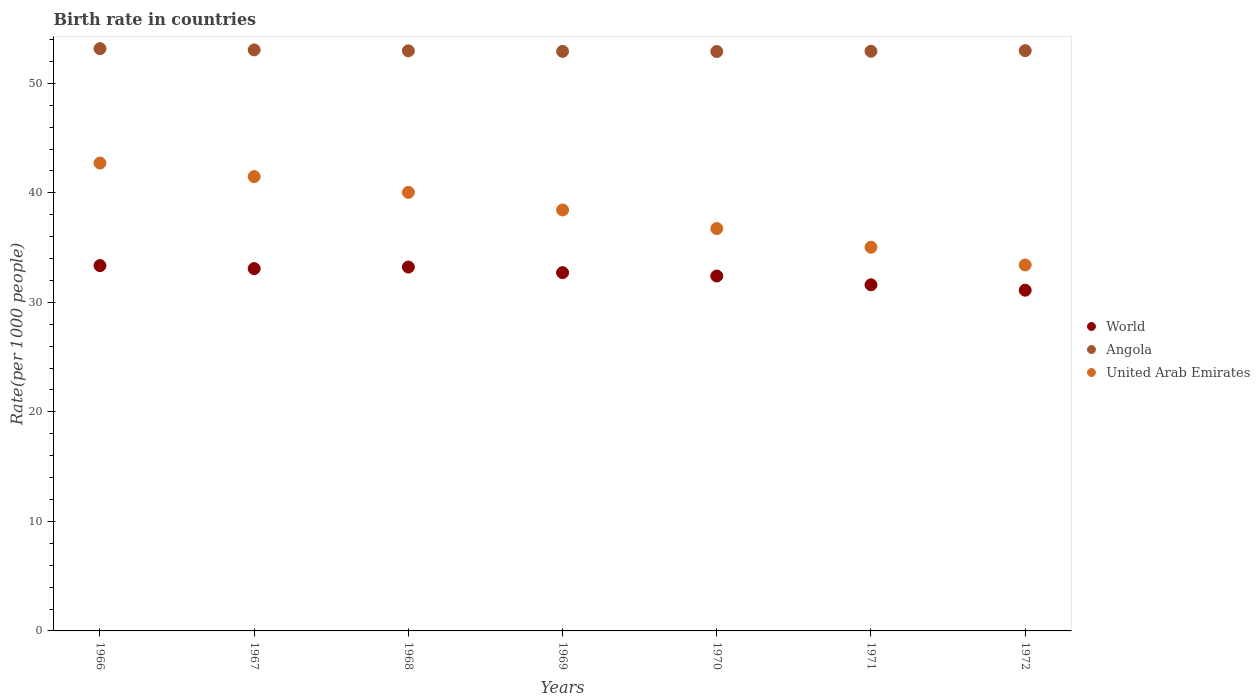Is the number of dotlines equal to the number of legend labels?
Provide a short and direct response. Yes. What is the birth rate in World in 1969?
Provide a short and direct response. 32.71. Across all years, what is the maximum birth rate in World?
Provide a succinct answer. 33.36. Across all years, what is the minimum birth rate in Angola?
Your answer should be very brief. 52.91. In which year was the birth rate in World maximum?
Offer a terse response. 1966. What is the total birth rate in United Arab Emirates in the graph?
Your response must be concise. 267.87. What is the difference between the birth rate in Angola in 1968 and that in 1970?
Make the answer very short. 0.06. What is the difference between the birth rate in United Arab Emirates in 1966 and the birth rate in World in 1972?
Offer a terse response. 11.61. What is the average birth rate in Angola per year?
Your answer should be very brief. 52.99. In the year 1967, what is the difference between the birth rate in United Arab Emirates and birth rate in Angola?
Your answer should be compact. -11.57. What is the ratio of the birth rate in Angola in 1966 to that in 1971?
Provide a succinct answer. 1. Is the birth rate in United Arab Emirates in 1966 less than that in 1969?
Give a very brief answer. No. Is the difference between the birth rate in United Arab Emirates in 1966 and 1971 greater than the difference between the birth rate in Angola in 1966 and 1971?
Provide a succinct answer. Yes. What is the difference between the highest and the second highest birth rate in World?
Provide a short and direct response. 0.13. What is the difference between the highest and the lowest birth rate in Angola?
Keep it short and to the point. 0.26. In how many years, is the birth rate in Angola greater than the average birth rate in Angola taken over all years?
Keep it short and to the point. 2. Does the birth rate in World monotonically increase over the years?
Offer a very short reply. No. How many dotlines are there?
Provide a succinct answer. 3. Are the values on the major ticks of Y-axis written in scientific E-notation?
Offer a very short reply. No. Does the graph contain any zero values?
Your answer should be compact. No. What is the title of the graph?
Make the answer very short. Birth rate in countries. Does "Burkina Faso" appear as one of the legend labels in the graph?
Your answer should be very brief. No. What is the label or title of the Y-axis?
Your answer should be compact. Rate(per 1000 people). What is the Rate(per 1000 people) in World in 1966?
Provide a succinct answer. 33.36. What is the Rate(per 1000 people) of Angola in 1966?
Give a very brief answer. 53.17. What is the Rate(per 1000 people) in United Arab Emirates in 1966?
Offer a very short reply. 42.72. What is the Rate(per 1000 people) of World in 1967?
Provide a succinct answer. 33.08. What is the Rate(per 1000 people) in Angola in 1967?
Provide a short and direct response. 53.05. What is the Rate(per 1000 people) of United Arab Emirates in 1967?
Offer a very short reply. 41.48. What is the Rate(per 1000 people) of World in 1968?
Provide a short and direct response. 33.22. What is the Rate(per 1000 people) in Angola in 1968?
Make the answer very short. 52.97. What is the Rate(per 1000 people) of United Arab Emirates in 1968?
Offer a terse response. 40.04. What is the Rate(per 1000 people) in World in 1969?
Offer a very short reply. 32.71. What is the Rate(per 1000 people) in Angola in 1969?
Your response must be concise. 52.92. What is the Rate(per 1000 people) of United Arab Emirates in 1969?
Offer a terse response. 38.44. What is the Rate(per 1000 people) of World in 1970?
Ensure brevity in your answer.  32.41. What is the Rate(per 1000 people) of Angola in 1970?
Offer a very short reply. 52.91. What is the Rate(per 1000 people) in United Arab Emirates in 1970?
Give a very brief answer. 36.74. What is the Rate(per 1000 people) of World in 1971?
Your response must be concise. 31.6. What is the Rate(per 1000 people) in Angola in 1971?
Keep it short and to the point. 52.93. What is the Rate(per 1000 people) of United Arab Emirates in 1971?
Provide a short and direct response. 35.03. What is the Rate(per 1000 people) in World in 1972?
Make the answer very short. 31.11. What is the Rate(per 1000 people) in Angola in 1972?
Provide a succinct answer. 52.98. What is the Rate(per 1000 people) in United Arab Emirates in 1972?
Keep it short and to the point. 33.41. Across all years, what is the maximum Rate(per 1000 people) of World?
Keep it short and to the point. 33.36. Across all years, what is the maximum Rate(per 1000 people) in Angola?
Make the answer very short. 53.17. Across all years, what is the maximum Rate(per 1000 people) in United Arab Emirates?
Your response must be concise. 42.72. Across all years, what is the minimum Rate(per 1000 people) of World?
Make the answer very short. 31.11. Across all years, what is the minimum Rate(per 1000 people) of Angola?
Provide a succinct answer. 52.91. Across all years, what is the minimum Rate(per 1000 people) in United Arab Emirates?
Provide a short and direct response. 33.41. What is the total Rate(per 1000 people) of World in the graph?
Your answer should be very brief. 227.5. What is the total Rate(per 1000 people) of Angola in the graph?
Provide a short and direct response. 370.92. What is the total Rate(per 1000 people) of United Arab Emirates in the graph?
Ensure brevity in your answer.  267.87. What is the difference between the Rate(per 1000 people) in World in 1966 and that in 1967?
Offer a terse response. 0.27. What is the difference between the Rate(per 1000 people) of Angola in 1966 and that in 1967?
Offer a very short reply. 0.12. What is the difference between the Rate(per 1000 people) in United Arab Emirates in 1966 and that in 1967?
Keep it short and to the point. 1.24. What is the difference between the Rate(per 1000 people) of World in 1966 and that in 1968?
Provide a succinct answer. 0.13. What is the difference between the Rate(per 1000 people) in Angola in 1966 and that in 1968?
Offer a very short reply. 0.2. What is the difference between the Rate(per 1000 people) in United Arab Emirates in 1966 and that in 1968?
Your answer should be very brief. 2.68. What is the difference between the Rate(per 1000 people) in World in 1966 and that in 1969?
Provide a short and direct response. 0.64. What is the difference between the Rate(per 1000 people) of Angola in 1966 and that in 1969?
Offer a very short reply. 0.25. What is the difference between the Rate(per 1000 people) of United Arab Emirates in 1966 and that in 1969?
Provide a succinct answer. 4.28. What is the difference between the Rate(per 1000 people) in World in 1966 and that in 1970?
Provide a succinct answer. 0.95. What is the difference between the Rate(per 1000 people) of Angola in 1966 and that in 1970?
Provide a short and direct response. 0.26. What is the difference between the Rate(per 1000 people) in United Arab Emirates in 1966 and that in 1970?
Your response must be concise. 5.98. What is the difference between the Rate(per 1000 people) in World in 1966 and that in 1971?
Your answer should be very brief. 1.75. What is the difference between the Rate(per 1000 people) of Angola in 1966 and that in 1971?
Offer a terse response. 0.24. What is the difference between the Rate(per 1000 people) in United Arab Emirates in 1966 and that in 1971?
Make the answer very short. 7.69. What is the difference between the Rate(per 1000 people) of World in 1966 and that in 1972?
Your answer should be very brief. 2.25. What is the difference between the Rate(per 1000 people) of Angola in 1966 and that in 1972?
Provide a succinct answer. 0.18. What is the difference between the Rate(per 1000 people) in United Arab Emirates in 1966 and that in 1972?
Your response must be concise. 9.31. What is the difference between the Rate(per 1000 people) of World in 1967 and that in 1968?
Keep it short and to the point. -0.14. What is the difference between the Rate(per 1000 people) in Angola in 1967 and that in 1968?
Offer a very short reply. 0.08. What is the difference between the Rate(per 1000 people) of United Arab Emirates in 1967 and that in 1968?
Give a very brief answer. 1.44. What is the difference between the Rate(per 1000 people) in World in 1967 and that in 1969?
Ensure brevity in your answer.  0.37. What is the difference between the Rate(per 1000 people) of Angola in 1967 and that in 1969?
Provide a succinct answer. 0.13. What is the difference between the Rate(per 1000 people) of United Arab Emirates in 1967 and that in 1969?
Provide a short and direct response. 3.04. What is the difference between the Rate(per 1000 people) in World in 1967 and that in 1970?
Your response must be concise. 0.68. What is the difference between the Rate(per 1000 people) in Angola in 1967 and that in 1970?
Make the answer very short. 0.15. What is the difference between the Rate(per 1000 people) of United Arab Emirates in 1967 and that in 1970?
Your answer should be very brief. 4.74. What is the difference between the Rate(per 1000 people) of World in 1967 and that in 1971?
Offer a very short reply. 1.48. What is the difference between the Rate(per 1000 people) in Angola in 1967 and that in 1971?
Make the answer very short. 0.12. What is the difference between the Rate(per 1000 people) in United Arab Emirates in 1967 and that in 1971?
Offer a terse response. 6.45. What is the difference between the Rate(per 1000 people) in World in 1967 and that in 1972?
Keep it short and to the point. 1.97. What is the difference between the Rate(per 1000 people) of Angola in 1967 and that in 1972?
Ensure brevity in your answer.  0.07. What is the difference between the Rate(per 1000 people) in United Arab Emirates in 1967 and that in 1972?
Give a very brief answer. 8.07. What is the difference between the Rate(per 1000 people) in World in 1968 and that in 1969?
Your answer should be very brief. 0.51. What is the difference between the Rate(per 1000 people) of Angola in 1968 and that in 1969?
Give a very brief answer. 0.05. What is the difference between the Rate(per 1000 people) of United Arab Emirates in 1968 and that in 1969?
Give a very brief answer. 1.6. What is the difference between the Rate(per 1000 people) of World in 1968 and that in 1970?
Keep it short and to the point. 0.82. What is the difference between the Rate(per 1000 people) of Angola in 1968 and that in 1970?
Provide a succinct answer. 0.06. What is the difference between the Rate(per 1000 people) in World in 1968 and that in 1971?
Provide a succinct answer. 1.62. What is the difference between the Rate(per 1000 people) in Angola in 1968 and that in 1971?
Provide a succinct answer. 0.04. What is the difference between the Rate(per 1000 people) in United Arab Emirates in 1968 and that in 1971?
Keep it short and to the point. 5.01. What is the difference between the Rate(per 1000 people) in World in 1968 and that in 1972?
Make the answer very short. 2.11. What is the difference between the Rate(per 1000 people) of Angola in 1968 and that in 1972?
Your response must be concise. -0.01. What is the difference between the Rate(per 1000 people) of United Arab Emirates in 1968 and that in 1972?
Ensure brevity in your answer.  6.63. What is the difference between the Rate(per 1000 people) in World in 1969 and that in 1970?
Offer a terse response. 0.31. What is the difference between the Rate(per 1000 people) in Angola in 1969 and that in 1970?
Offer a very short reply. 0.01. What is the difference between the Rate(per 1000 people) of United Arab Emirates in 1969 and that in 1970?
Provide a short and direct response. 1.7. What is the difference between the Rate(per 1000 people) in World in 1969 and that in 1971?
Your response must be concise. 1.11. What is the difference between the Rate(per 1000 people) in Angola in 1969 and that in 1971?
Keep it short and to the point. -0.01. What is the difference between the Rate(per 1000 people) in United Arab Emirates in 1969 and that in 1971?
Your answer should be compact. 3.4. What is the difference between the Rate(per 1000 people) in World in 1969 and that in 1972?
Make the answer very short. 1.6. What is the difference between the Rate(per 1000 people) in Angola in 1969 and that in 1972?
Give a very brief answer. -0.06. What is the difference between the Rate(per 1000 people) in United Arab Emirates in 1969 and that in 1972?
Make the answer very short. 5.02. What is the difference between the Rate(per 1000 people) in World in 1970 and that in 1971?
Provide a short and direct response. 0.8. What is the difference between the Rate(per 1000 people) of Angola in 1970 and that in 1971?
Give a very brief answer. -0.02. What is the difference between the Rate(per 1000 people) of United Arab Emirates in 1970 and that in 1971?
Offer a very short reply. 1.71. What is the difference between the Rate(per 1000 people) in World in 1970 and that in 1972?
Ensure brevity in your answer.  1.3. What is the difference between the Rate(per 1000 people) in Angola in 1970 and that in 1972?
Keep it short and to the point. -0.08. What is the difference between the Rate(per 1000 people) of United Arab Emirates in 1970 and that in 1972?
Ensure brevity in your answer.  3.33. What is the difference between the Rate(per 1000 people) of World in 1971 and that in 1972?
Provide a short and direct response. 0.49. What is the difference between the Rate(per 1000 people) in Angola in 1971 and that in 1972?
Keep it short and to the point. -0.06. What is the difference between the Rate(per 1000 people) of United Arab Emirates in 1971 and that in 1972?
Give a very brief answer. 1.62. What is the difference between the Rate(per 1000 people) of World in 1966 and the Rate(per 1000 people) of Angola in 1967?
Give a very brief answer. -19.69. What is the difference between the Rate(per 1000 people) of World in 1966 and the Rate(per 1000 people) of United Arab Emirates in 1967?
Offer a very short reply. -8.13. What is the difference between the Rate(per 1000 people) of Angola in 1966 and the Rate(per 1000 people) of United Arab Emirates in 1967?
Offer a very short reply. 11.68. What is the difference between the Rate(per 1000 people) of World in 1966 and the Rate(per 1000 people) of Angola in 1968?
Offer a terse response. -19.61. What is the difference between the Rate(per 1000 people) in World in 1966 and the Rate(per 1000 people) in United Arab Emirates in 1968?
Provide a short and direct response. -6.68. What is the difference between the Rate(per 1000 people) of Angola in 1966 and the Rate(per 1000 people) of United Arab Emirates in 1968?
Your answer should be very brief. 13.12. What is the difference between the Rate(per 1000 people) in World in 1966 and the Rate(per 1000 people) in Angola in 1969?
Make the answer very short. -19.56. What is the difference between the Rate(per 1000 people) in World in 1966 and the Rate(per 1000 people) in United Arab Emirates in 1969?
Offer a terse response. -5.08. What is the difference between the Rate(per 1000 people) in Angola in 1966 and the Rate(per 1000 people) in United Arab Emirates in 1969?
Your answer should be very brief. 14.73. What is the difference between the Rate(per 1000 people) in World in 1966 and the Rate(per 1000 people) in Angola in 1970?
Provide a succinct answer. -19.55. What is the difference between the Rate(per 1000 people) of World in 1966 and the Rate(per 1000 people) of United Arab Emirates in 1970?
Offer a terse response. -3.38. What is the difference between the Rate(per 1000 people) of Angola in 1966 and the Rate(per 1000 people) of United Arab Emirates in 1970?
Keep it short and to the point. 16.43. What is the difference between the Rate(per 1000 people) of World in 1966 and the Rate(per 1000 people) of Angola in 1971?
Your answer should be compact. -19.57. What is the difference between the Rate(per 1000 people) in World in 1966 and the Rate(per 1000 people) in United Arab Emirates in 1971?
Your answer should be compact. -1.68. What is the difference between the Rate(per 1000 people) in Angola in 1966 and the Rate(per 1000 people) in United Arab Emirates in 1971?
Make the answer very short. 18.13. What is the difference between the Rate(per 1000 people) of World in 1966 and the Rate(per 1000 people) of Angola in 1972?
Provide a succinct answer. -19.63. What is the difference between the Rate(per 1000 people) in World in 1966 and the Rate(per 1000 people) in United Arab Emirates in 1972?
Your answer should be compact. -0.06. What is the difference between the Rate(per 1000 people) of Angola in 1966 and the Rate(per 1000 people) of United Arab Emirates in 1972?
Ensure brevity in your answer.  19.75. What is the difference between the Rate(per 1000 people) of World in 1967 and the Rate(per 1000 people) of Angola in 1968?
Provide a succinct answer. -19.89. What is the difference between the Rate(per 1000 people) in World in 1967 and the Rate(per 1000 people) in United Arab Emirates in 1968?
Your response must be concise. -6.96. What is the difference between the Rate(per 1000 people) of Angola in 1967 and the Rate(per 1000 people) of United Arab Emirates in 1968?
Provide a short and direct response. 13.01. What is the difference between the Rate(per 1000 people) of World in 1967 and the Rate(per 1000 people) of Angola in 1969?
Your answer should be compact. -19.84. What is the difference between the Rate(per 1000 people) of World in 1967 and the Rate(per 1000 people) of United Arab Emirates in 1969?
Provide a succinct answer. -5.36. What is the difference between the Rate(per 1000 people) of Angola in 1967 and the Rate(per 1000 people) of United Arab Emirates in 1969?
Keep it short and to the point. 14.61. What is the difference between the Rate(per 1000 people) of World in 1967 and the Rate(per 1000 people) of Angola in 1970?
Provide a succinct answer. -19.82. What is the difference between the Rate(per 1000 people) of World in 1967 and the Rate(per 1000 people) of United Arab Emirates in 1970?
Provide a short and direct response. -3.66. What is the difference between the Rate(per 1000 people) of Angola in 1967 and the Rate(per 1000 people) of United Arab Emirates in 1970?
Give a very brief answer. 16.31. What is the difference between the Rate(per 1000 people) of World in 1967 and the Rate(per 1000 people) of Angola in 1971?
Your answer should be compact. -19.85. What is the difference between the Rate(per 1000 people) of World in 1967 and the Rate(per 1000 people) of United Arab Emirates in 1971?
Offer a very short reply. -1.95. What is the difference between the Rate(per 1000 people) in Angola in 1967 and the Rate(per 1000 people) in United Arab Emirates in 1971?
Keep it short and to the point. 18.02. What is the difference between the Rate(per 1000 people) of World in 1967 and the Rate(per 1000 people) of Angola in 1972?
Your answer should be very brief. -19.9. What is the difference between the Rate(per 1000 people) of World in 1967 and the Rate(per 1000 people) of United Arab Emirates in 1972?
Make the answer very short. -0.33. What is the difference between the Rate(per 1000 people) in Angola in 1967 and the Rate(per 1000 people) in United Arab Emirates in 1972?
Your response must be concise. 19.64. What is the difference between the Rate(per 1000 people) in World in 1968 and the Rate(per 1000 people) in Angola in 1969?
Your answer should be very brief. -19.69. What is the difference between the Rate(per 1000 people) in World in 1968 and the Rate(per 1000 people) in United Arab Emirates in 1969?
Your response must be concise. -5.21. What is the difference between the Rate(per 1000 people) of Angola in 1968 and the Rate(per 1000 people) of United Arab Emirates in 1969?
Your answer should be compact. 14.53. What is the difference between the Rate(per 1000 people) of World in 1968 and the Rate(per 1000 people) of Angola in 1970?
Provide a short and direct response. -19.68. What is the difference between the Rate(per 1000 people) in World in 1968 and the Rate(per 1000 people) in United Arab Emirates in 1970?
Offer a terse response. -3.52. What is the difference between the Rate(per 1000 people) in Angola in 1968 and the Rate(per 1000 people) in United Arab Emirates in 1970?
Provide a succinct answer. 16.23. What is the difference between the Rate(per 1000 people) in World in 1968 and the Rate(per 1000 people) in Angola in 1971?
Your answer should be very brief. -19.7. What is the difference between the Rate(per 1000 people) in World in 1968 and the Rate(per 1000 people) in United Arab Emirates in 1971?
Make the answer very short. -1.81. What is the difference between the Rate(per 1000 people) in Angola in 1968 and the Rate(per 1000 people) in United Arab Emirates in 1971?
Your answer should be compact. 17.93. What is the difference between the Rate(per 1000 people) in World in 1968 and the Rate(per 1000 people) in Angola in 1972?
Provide a succinct answer. -19.76. What is the difference between the Rate(per 1000 people) in World in 1968 and the Rate(per 1000 people) in United Arab Emirates in 1972?
Your answer should be very brief. -0.19. What is the difference between the Rate(per 1000 people) of Angola in 1968 and the Rate(per 1000 people) of United Arab Emirates in 1972?
Provide a succinct answer. 19.55. What is the difference between the Rate(per 1000 people) in World in 1969 and the Rate(per 1000 people) in Angola in 1970?
Your answer should be compact. -20.19. What is the difference between the Rate(per 1000 people) of World in 1969 and the Rate(per 1000 people) of United Arab Emirates in 1970?
Your response must be concise. -4.03. What is the difference between the Rate(per 1000 people) of Angola in 1969 and the Rate(per 1000 people) of United Arab Emirates in 1970?
Provide a short and direct response. 16.18. What is the difference between the Rate(per 1000 people) in World in 1969 and the Rate(per 1000 people) in Angola in 1971?
Keep it short and to the point. -20.21. What is the difference between the Rate(per 1000 people) of World in 1969 and the Rate(per 1000 people) of United Arab Emirates in 1971?
Offer a very short reply. -2.32. What is the difference between the Rate(per 1000 people) in Angola in 1969 and the Rate(per 1000 people) in United Arab Emirates in 1971?
Your answer should be very brief. 17.89. What is the difference between the Rate(per 1000 people) of World in 1969 and the Rate(per 1000 people) of Angola in 1972?
Make the answer very short. -20.27. What is the difference between the Rate(per 1000 people) in World in 1969 and the Rate(per 1000 people) in United Arab Emirates in 1972?
Ensure brevity in your answer.  -0.7. What is the difference between the Rate(per 1000 people) of Angola in 1969 and the Rate(per 1000 people) of United Arab Emirates in 1972?
Offer a terse response. 19.5. What is the difference between the Rate(per 1000 people) of World in 1970 and the Rate(per 1000 people) of Angola in 1971?
Your answer should be compact. -20.52. What is the difference between the Rate(per 1000 people) of World in 1970 and the Rate(per 1000 people) of United Arab Emirates in 1971?
Provide a succinct answer. -2.63. What is the difference between the Rate(per 1000 people) of Angola in 1970 and the Rate(per 1000 people) of United Arab Emirates in 1971?
Your answer should be compact. 17.87. What is the difference between the Rate(per 1000 people) of World in 1970 and the Rate(per 1000 people) of Angola in 1972?
Provide a succinct answer. -20.58. What is the difference between the Rate(per 1000 people) of World in 1970 and the Rate(per 1000 people) of United Arab Emirates in 1972?
Offer a very short reply. -1.01. What is the difference between the Rate(per 1000 people) of Angola in 1970 and the Rate(per 1000 people) of United Arab Emirates in 1972?
Your answer should be very brief. 19.49. What is the difference between the Rate(per 1000 people) in World in 1971 and the Rate(per 1000 people) in Angola in 1972?
Provide a short and direct response. -21.38. What is the difference between the Rate(per 1000 people) of World in 1971 and the Rate(per 1000 people) of United Arab Emirates in 1972?
Offer a very short reply. -1.81. What is the difference between the Rate(per 1000 people) of Angola in 1971 and the Rate(per 1000 people) of United Arab Emirates in 1972?
Ensure brevity in your answer.  19.51. What is the average Rate(per 1000 people) in World per year?
Offer a terse response. 32.5. What is the average Rate(per 1000 people) of Angola per year?
Offer a terse response. 52.99. What is the average Rate(per 1000 people) in United Arab Emirates per year?
Your response must be concise. 38.27. In the year 1966, what is the difference between the Rate(per 1000 people) of World and Rate(per 1000 people) of Angola?
Ensure brevity in your answer.  -19.81. In the year 1966, what is the difference between the Rate(per 1000 people) of World and Rate(per 1000 people) of United Arab Emirates?
Give a very brief answer. -9.37. In the year 1966, what is the difference between the Rate(per 1000 people) of Angola and Rate(per 1000 people) of United Arab Emirates?
Your answer should be compact. 10.44. In the year 1967, what is the difference between the Rate(per 1000 people) in World and Rate(per 1000 people) in Angola?
Offer a terse response. -19.97. In the year 1967, what is the difference between the Rate(per 1000 people) in World and Rate(per 1000 people) in United Arab Emirates?
Give a very brief answer. -8.4. In the year 1967, what is the difference between the Rate(per 1000 people) of Angola and Rate(per 1000 people) of United Arab Emirates?
Your response must be concise. 11.57. In the year 1968, what is the difference between the Rate(per 1000 people) of World and Rate(per 1000 people) of Angola?
Make the answer very short. -19.74. In the year 1968, what is the difference between the Rate(per 1000 people) of World and Rate(per 1000 people) of United Arab Emirates?
Offer a terse response. -6.82. In the year 1968, what is the difference between the Rate(per 1000 people) in Angola and Rate(per 1000 people) in United Arab Emirates?
Provide a short and direct response. 12.93. In the year 1969, what is the difference between the Rate(per 1000 people) of World and Rate(per 1000 people) of Angola?
Offer a very short reply. -20.21. In the year 1969, what is the difference between the Rate(per 1000 people) in World and Rate(per 1000 people) in United Arab Emirates?
Offer a very short reply. -5.72. In the year 1969, what is the difference between the Rate(per 1000 people) of Angola and Rate(per 1000 people) of United Arab Emirates?
Offer a terse response. 14.48. In the year 1970, what is the difference between the Rate(per 1000 people) in World and Rate(per 1000 people) in Angola?
Your response must be concise. -20.5. In the year 1970, what is the difference between the Rate(per 1000 people) in World and Rate(per 1000 people) in United Arab Emirates?
Offer a terse response. -4.34. In the year 1970, what is the difference between the Rate(per 1000 people) in Angola and Rate(per 1000 people) in United Arab Emirates?
Offer a terse response. 16.16. In the year 1971, what is the difference between the Rate(per 1000 people) in World and Rate(per 1000 people) in Angola?
Your response must be concise. -21.32. In the year 1971, what is the difference between the Rate(per 1000 people) in World and Rate(per 1000 people) in United Arab Emirates?
Make the answer very short. -3.43. In the year 1971, what is the difference between the Rate(per 1000 people) in Angola and Rate(per 1000 people) in United Arab Emirates?
Ensure brevity in your answer.  17.89. In the year 1972, what is the difference between the Rate(per 1000 people) of World and Rate(per 1000 people) of Angola?
Provide a succinct answer. -21.87. In the year 1972, what is the difference between the Rate(per 1000 people) of World and Rate(per 1000 people) of United Arab Emirates?
Your response must be concise. -2.3. In the year 1972, what is the difference between the Rate(per 1000 people) in Angola and Rate(per 1000 people) in United Arab Emirates?
Keep it short and to the point. 19.57. What is the ratio of the Rate(per 1000 people) of World in 1966 to that in 1967?
Your answer should be compact. 1.01. What is the ratio of the Rate(per 1000 people) in Angola in 1966 to that in 1967?
Provide a succinct answer. 1. What is the ratio of the Rate(per 1000 people) of United Arab Emirates in 1966 to that in 1967?
Provide a succinct answer. 1.03. What is the ratio of the Rate(per 1000 people) of World in 1966 to that in 1968?
Give a very brief answer. 1. What is the ratio of the Rate(per 1000 people) of United Arab Emirates in 1966 to that in 1968?
Provide a short and direct response. 1.07. What is the ratio of the Rate(per 1000 people) of World in 1966 to that in 1969?
Provide a short and direct response. 1.02. What is the ratio of the Rate(per 1000 people) in United Arab Emirates in 1966 to that in 1969?
Keep it short and to the point. 1.11. What is the ratio of the Rate(per 1000 people) of World in 1966 to that in 1970?
Ensure brevity in your answer.  1.03. What is the ratio of the Rate(per 1000 people) of United Arab Emirates in 1966 to that in 1970?
Provide a short and direct response. 1.16. What is the ratio of the Rate(per 1000 people) in World in 1966 to that in 1971?
Make the answer very short. 1.06. What is the ratio of the Rate(per 1000 people) in United Arab Emirates in 1966 to that in 1971?
Make the answer very short. 1.22. What is the ratio of the Rate(per 1000 people) in World in 1966 to that in 1972?
Offer a very short reply. 1.07. What is the ratio of the Rate(per 1000 people) in Angola in 1966 to that in 1972?
Give a very brief answer. 1. What is the ratio of the Rate(per 1000 people) in United Arab Emirates in 1966 to that in 1972?
Ensure brevity in your answer.  1.28. What is the ratio of the Rate(per 1000 people) of World in 1967 to that in 1968?
Your answer should be very brief. 1. What is the ratio of the Rate(per 1000 people) in Angola in 1967 to that in 1968?
Keep it short and to the point. 1. What is the ratio of the Rate(per 1000 people) of United Arab Emirates in 1967 to that in 1968?
Your answer should be compact. 1.04. What is the ratio of the Rate(per 1000 people) of World in 1967 to that in 1969?
Ensure brevity in your answer.  1.01. What is the ratio of the Rate(per 1000 people) of United Arab Emirates in 1967 to that in 1969?
Keep it short and to the point. 1.08. What is the ratio of the Rate(per 1000 people) of World in 1967 to that in 1970?
Offer a very short reply. 1.02. What is the ratio of the Rate(per 1000 people) in Angola in 1967 to that in 1970?
Make the answer very short. 1. What is the ratio of the Rate(per 1000 people) of United Arab Emirates in 1967 to that in 1970?
Provide a short and direct response. 1.13. What is the ratio of the Rate(per 1000 people) of World in 1967 to that in 1971?
Give a very brief answer. 1.05. What is the ratio of the Rate(per 1000 people) in Angola in 1967 to that in 1971?
Your response must be concise. 1. What is the ratio of the Rate(per 1000 people) in United Arab Emirates in 1967 to that in 1971?
Your answer should be very brief. 1.18. What is the ratio of the Rate(per 1000 people) in World in 1967 to that in 1972?
Provide a short and direct response. 1.06. What is the ratio of the Rate(per 1000 people) in United Arab Emirates in 1967 to that in 1972?
Make the answer very short. 1.24. What is the ratio of the Rate(per 1000 people) in World in 1968 to that in 1969?
Your answer should be compact. 1.02. What is the ratio of the Rate(per 1000 people) of Angola in 1968 to that in 1969?
Provide a succinct answer. 1. What is the ratio of the Rate(per 1000 people) of United Arab Emirates in 1968 to that in 1969?
Offer a terse response. 1.04. What is the ratio of the Rate(per 1000 people) in World in 1968 to that in 1970?
Offer a very short reply. 1.03. What is the ratio of the Rate(per 1000 people) in Angola in 1968 to that in 1970?
Provide a short and direct response. 1. What is the ratio of the Rate(per 1000 people) in United Arab Emirates in 1968 to that in 1970?
Give a very brief answer. 1.09. What is the ratio of the Rate(per 1000 people) in World in 1968 to that in 1971?
Ensure brevity in your answer.  1.05. What is the ratio of the Rate(per 1000 people) in United Arab Emirates in 1968 to that in 1971?
Offer a very short reply. 1.14. What is the ratio of the Rate(per 1000 people) of World in 1968 to that in 1972?
Your answer should be compact. 1.07. What is the ratio of the Rate(per 1000 people) of Angola in 1968 to that in 1972?
Ensure brevity in your answer.  1. What is the ratio of the Rate(per 1000 people) in United Arab Emirates in 1968 to that in 1972?
Ensure brevity in your answer.  1.2. What is the ratio of the Rate(per 1000 people) of World in 1969 to that in 1970?
Provide a short and direct response. 1.01. What is the ratio of the Rate(per 1000 people) in Angola in 1969 to that in 1970?
Offer a very short reply. 1. What is the ratio of the Rate(per 1000 people) in United Arab Emirates in 1969 to that in 1970?
Ensure brevity in your answer.  1.05. What is the ratio of the Rate(per 1000 people) in World in 1969 to that in 1971?
Keep it short and to the point. 1.04. What is the ratio of the Rate(per 1000 people) of Angola in 1969 to that in 1971?
Your response must be concise. 1. What is the ratio of the Rate(per 1000 people) of United Arab Emirates in 1969 to that in 1971?
Your answer should be compact. 1.1. What is the ratio of the Rate(per 1000 people) of World in 1969 to that in 1972?
Provide a succinct answer. 1.05. What is the ratio of the Rate(per 1000 people) in Angola in 1969 to that in 1972?
Make the answer very short. 1. What is the ratio of the Rate(per 1000 people) of United Arab Emirates in 1969 to that in 1972?
Offer a terse response. 1.15. What is the ratio of the Rate(per 1000 people) of World in 1970 to that in 1971?
Your answer should be very brief. 1.03. What is the ratio of the Rate(per 1000 people) in United Arab Emirates in 1970 to that in 1971?
Your answer should be very brief. 1.05. What is the ratio of the Rate(per 1000 people) of World in 1970 to that in 1972?
Provide a succinct answer. 1.04. What is the ratio of the Rate(per 1000 people) in United Arab Emirates in 1970 to that in 1972?
Give a very brief answer. 1.1. What is the ratio of the Rate(per 1000 people) of World in 1971 to that in 1972?
Keep it short and to the point. 1.02. What is the ratio of the Rate(per 1000 people) of Angola in 1971 to that in 1972?
Offer a very short reply. 1. What is the ratio of the Rate(per 1000 people) of United Arab Emirates in 1971 to that in 1972?
Offer a terse response. 1.05. What is the difference between the highest and the second highest Rate(per 1000 people) of World?
Your answer should be compact. 0.13. What is the difference between the highest and the second highest Rate(per 1000 people) of Angola?
Your answer should be compact. 0.12. What is the difference between the highest and the second highest Rate(per 1000 people) of United Arab Emirates?
Your response must be concise. 1.24. What is the difference between the highest and the lowest Rate(per 1000 people) in World?
Your response must be concise. 2.25. What is the difference between the highest and the lowest Rate(per 1000 people) in Angola?
Your answer should be compact. 0.26. What is the difference between the highest and the lowest Rate(per 1000 people) of United Arab Emirates?
Offer a terse response. 9.31. 